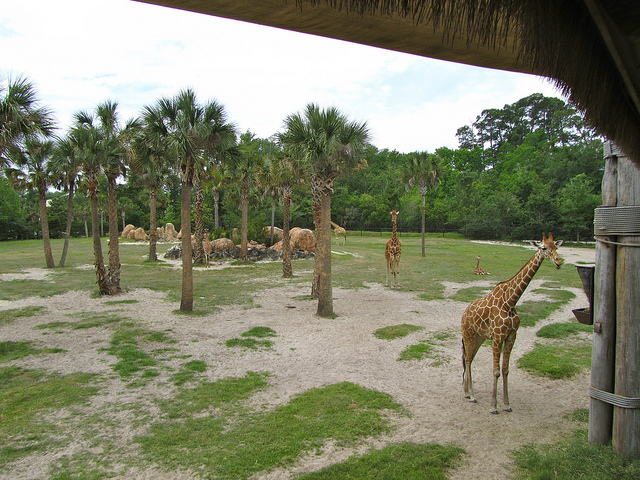<image>What is the smell? It is unknown what the smell is. What is the smell? I don't know what the smell is. It can be animals, giraffes, poop, dirt, or giraffe poop. 